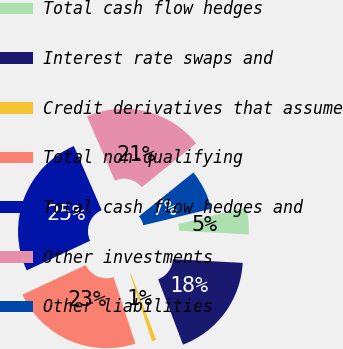Convert chart. <chart><loc_0><loc_0><loc_500><loc_500><pie_chart><fcel>Total cash flow hedges<fcel>Interest rate swaps and<fcel>Credit derivatives that assume<fcel>Total non-qualifying<fcel>Total cash flow hedges and<fcel>Other investments<fcel>Other liabilities<nl><fcel>4.65%<fcel>18.37%<fcel>0.74%<fcel>23.08%<fcel>25.43%<fcel>20.73%<fcel>7.0%<nl></chart> 